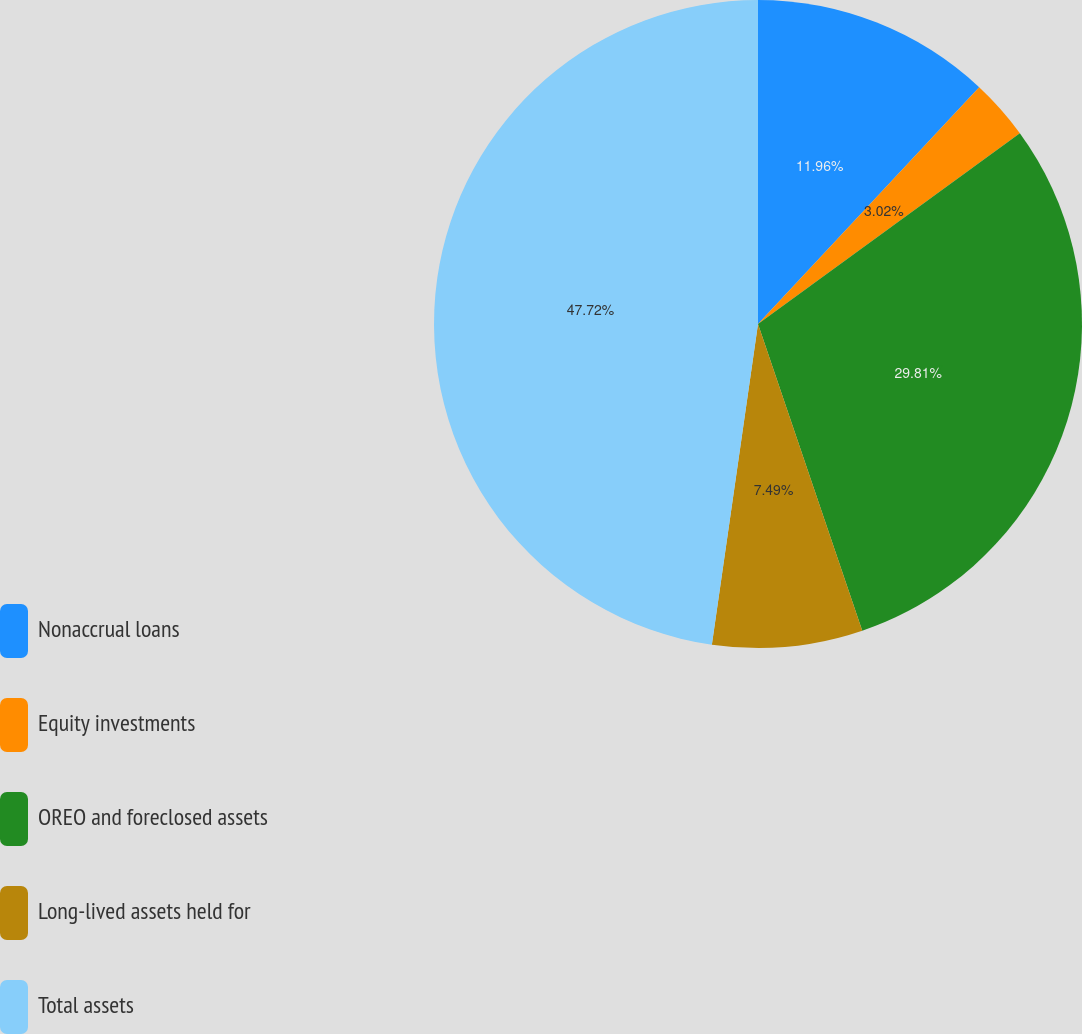Convert chart to OTSL. <chart><loc_0><loc_0><loc_500><loc_500><pie_chart><fcel>Nonaccrual loans<fcel>Equity investments<fcel>OREO and foreclosed assets<fcel>Long-lived assets held for<fcel>Total assets<nl><fcel>11.96%<fcel>3.02%<fcel>29.81%<fcel>7.49%<fcel>47.73%<nl></chart> 